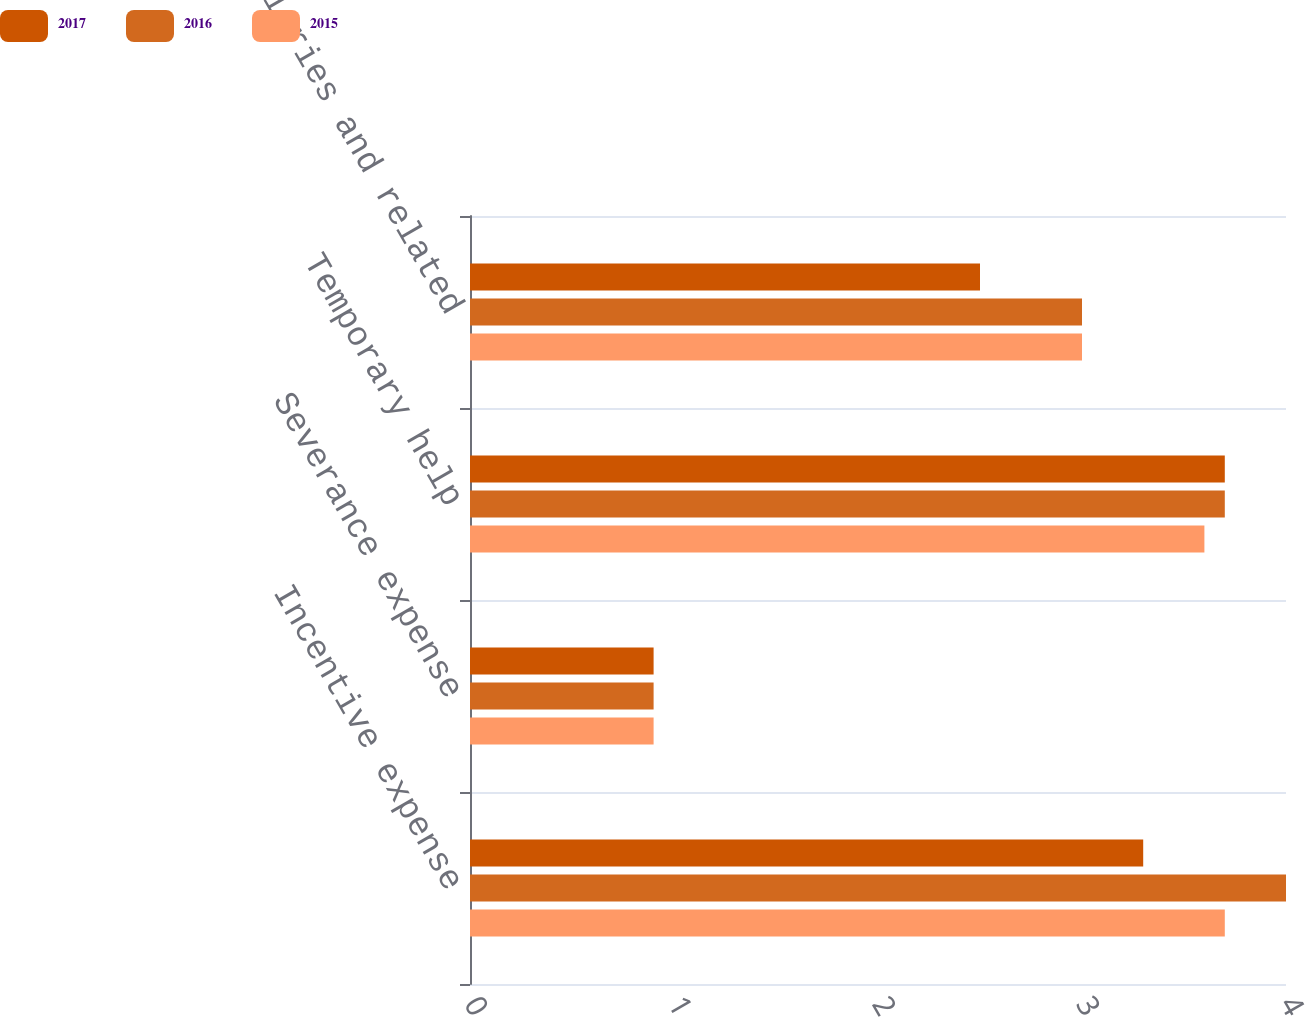Convert chart to OTSL. <chart><loc_0><loc_0><loc_500><loc_500><stacked_bar_chart><ecel><fcel>Incentive expense<fcel>Severance expense<fcel>Temporary help<fcel>All other salaries and related<nl><fcel>2017<fcel>3.3<fcel>0.9<fcel>3.7<fcel>2.5<nl><fcel>2016<fcel>4<fcel>0.9<fcel>3.7<fcel>3<nl><fcel>2015<fcel>3.7<fcel>0.9<fcel>3.6<fcel>3<nl></chart> 